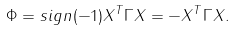Convert formula to latex. <formula><loc_0><loc_0><loc_500><loc_500>\Phi = s i g n ( - 1 ) X ^ { T } \Gamma X = - X ^ { T } \Gamma X .</formula> 